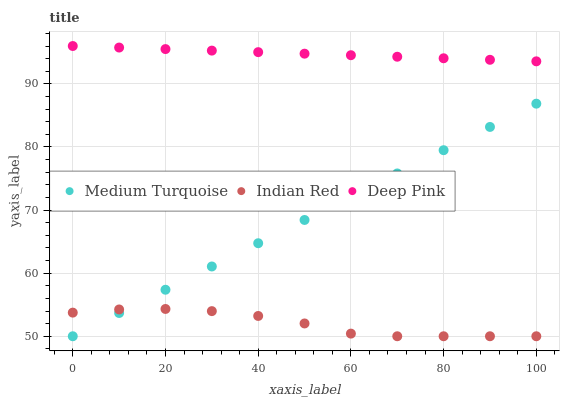Does Indian Red have the minimum area under the curve?
Answer yes or no. Yes. Does Deep Pink have the maximum area under the curve?
Answer yes or no. Yes. Does Medium Turquoise have the minimum area under the curve?
Answer yes or no. No. Does Medium Turquoise have the maximum area under the curve?
Answer yes or no. No. Is Medium Turquoise the smoothest?
Answer yes or no. Yes. Is Indian Red the roughest?
Answer yes or no. Yes. Is Indian Red the smoothest?
Answer yes or no. No. Is Medium Turquoise the roughest?
Answer yes or no. No. Does Indian Red have the lowest value?
Answer yes or no. Yes. Does Deep Pink have the highest value?
Answer yes or no. Yes. Does Medium Turquoise have the highest value?
Answer yes or no. No. Is Indian Red less than Deep Pink?
Answer yes or no. Yes. Is Deep Pink greater than Indian Red?
Answer yes or no. Yes. Does Medium Turquoise intersect Indian Red?
Answer yes or no. Yes. Is Medium Turquoise less than Indian Red?
Answer yes or no. No. Is Medium Turquoise greater than Indian Red?
Answer yes or no. No. Does Indian Red intersect Deep Pink?
Answer yes or no. No. 